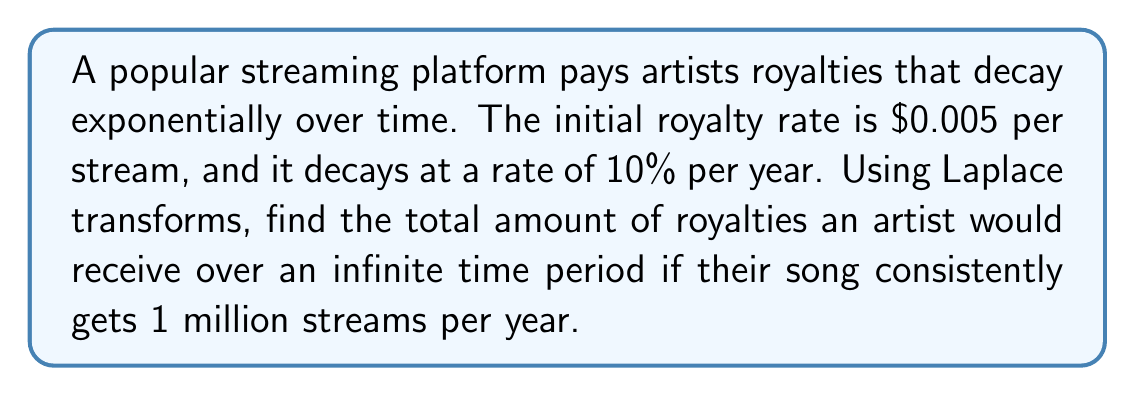Provide a solution to this math problem. Let's approach this step-by-step:

1) First, we need to model the royalty rate as a function of time. The exponential decay function is:

   $$R(t) = 0.005 \cdot e^{-0.1t}$$

   where $R(t)$ is the royalty rate (in dollars per stream) at time $t$ (in years).

2) The total royalties per year would be this rate multiplied by the number of streams:

   $$f(t) = 1,000,000 \cdot 0.005 \cdot e^{-0.1t} = 5000 \cdot e^{-0.1t}$$

3) To find the total amount over an infinite time period, we need to integrate this function from 0 to infinity. This is where Laplace transforms are useful.

4) The Laplace transform of $f(t)$ is:

   $$F(s) = \mathcal{L}\{f(t)\} = \int_0^\infty f(t)e^{-st}dt$$

5) For our function $f(t) = 5000 \cdot e^{-0.1t}$, the Laplace transform is:

   $$F(s) = 5000 \cdot \frac{1}{s + 0.1}$$

6) The total amount over an infinite time period is given by the final value theorem:

   $$\lim_{t \to \infty} f(t) = \lim_{s \to 0} sF(s)$$

7) Applying this:

   $$\lim_{s \to 0} s \cdot 5000 \cdot \frac{1}{s + 0.1} = 5000 \cdot \lim_{s \to 0} \frac{s}{s + 0.1} = 5000 \cdot \frac{0}{0.1} = 50,000$$

Therefore, the total amount of royalties the artist would receive over an infinite time period is $50,000.
Answer: $50,000 